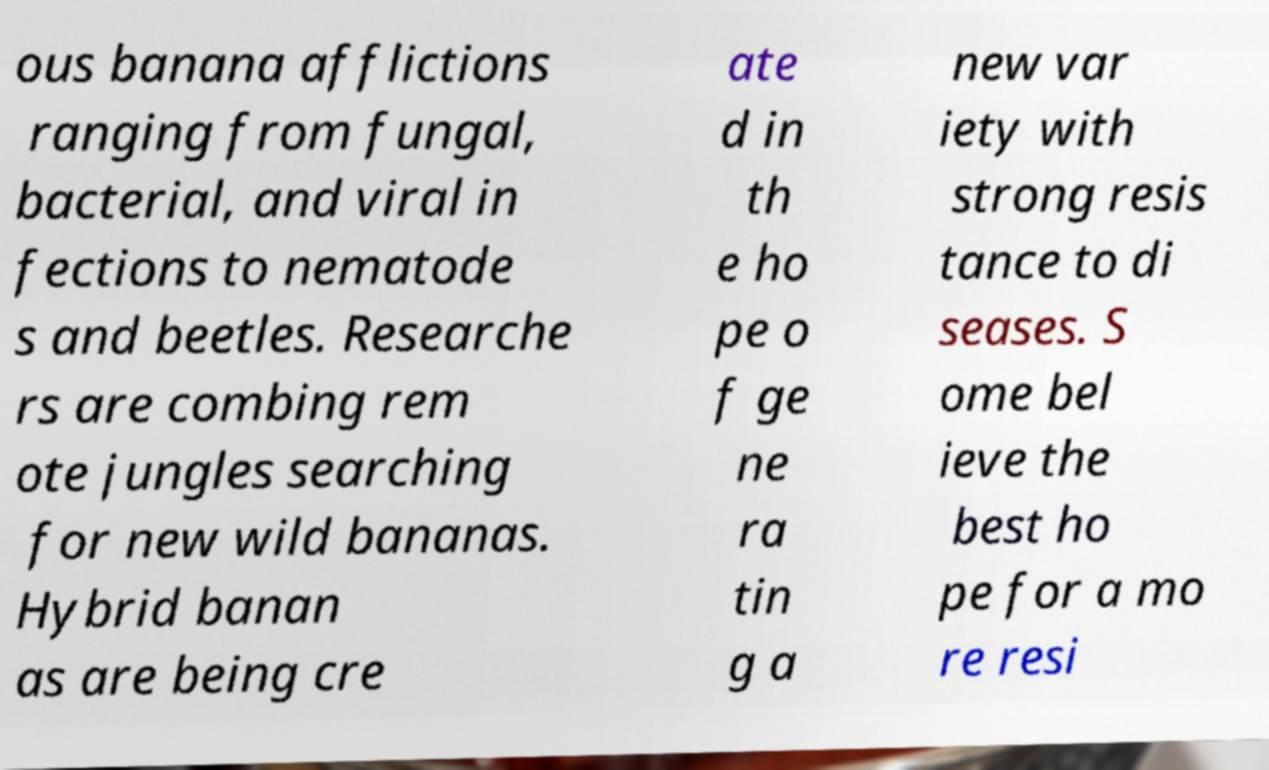Can you accurately transcribe the text from the provided image for me? ous banana afflictions ranging from fungal, bacterial, and viral in fections to nematode s and beetles. Researche rs are combing rem ote jungles searching for new wild bananas. Hybrid banan as are being cre ate d in th e ho pe o f ge ne ra tin g a new var iety with strong resis tance to di seases. S ome bel ieve the best ho pe for a mo re resi 